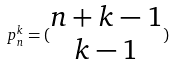<formula> <loc_0><loc_0><loc_500><loc_500>p _ { n } ^ { k } = ( \begin{matrix} n + k - 1 \\ k - 1 \end{matrix} )</formula> 